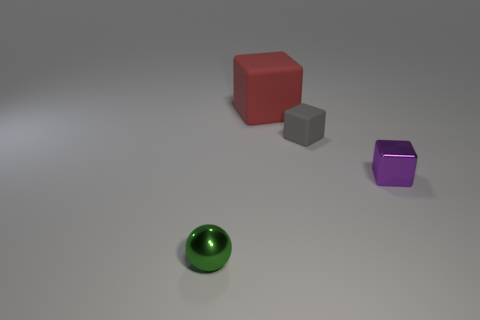Subtract 1 blocks. How many blocks are left? 2 Subtract all large red matte cubes. How many cubes are left? 2 Add 1 purple objects. How many objects exist? 5 Subtract all gray blocks. How many blocks are left? 2 Subtract all green spheres. How many red blocks are left? 1 Subtract all balls. How many objects are left? 3 Add 2 red rubber things. How many red rubber things are left? 3 Add 3 big gray matte objects. How many big gray matte objects exist? 3 Subtract 0 blue cubes. How many objects are left? 4 Subtract all cyan balls. Subtract all red cubes. How many balls are left? 1 